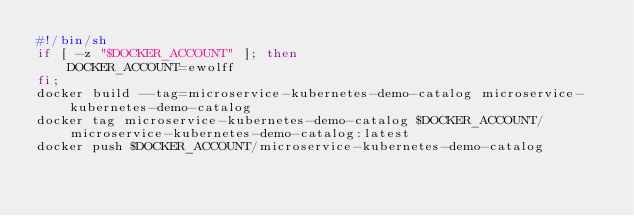Convert code to text. <code><loc_0><loc_0><loc_500><loc_500><_Bash_>#!/bin/sh
if [ -z "$DOCKER_ACCOUNT" ]; then
    DOCKER_ACCOUNT=ewolff
fi;
docker build --tag=microservice-kubernetes-demo-catalog microservice-kubernetes-demo-catalog
docker tag microservice-kubernetes-demo-catalog $DOCKER_ACCOUNT/microservice-kubernetes-demo-catalog:latest
docker push $DOCKER_ACCOUNT/microservice-kubernetes-demo-catalog
</code> 